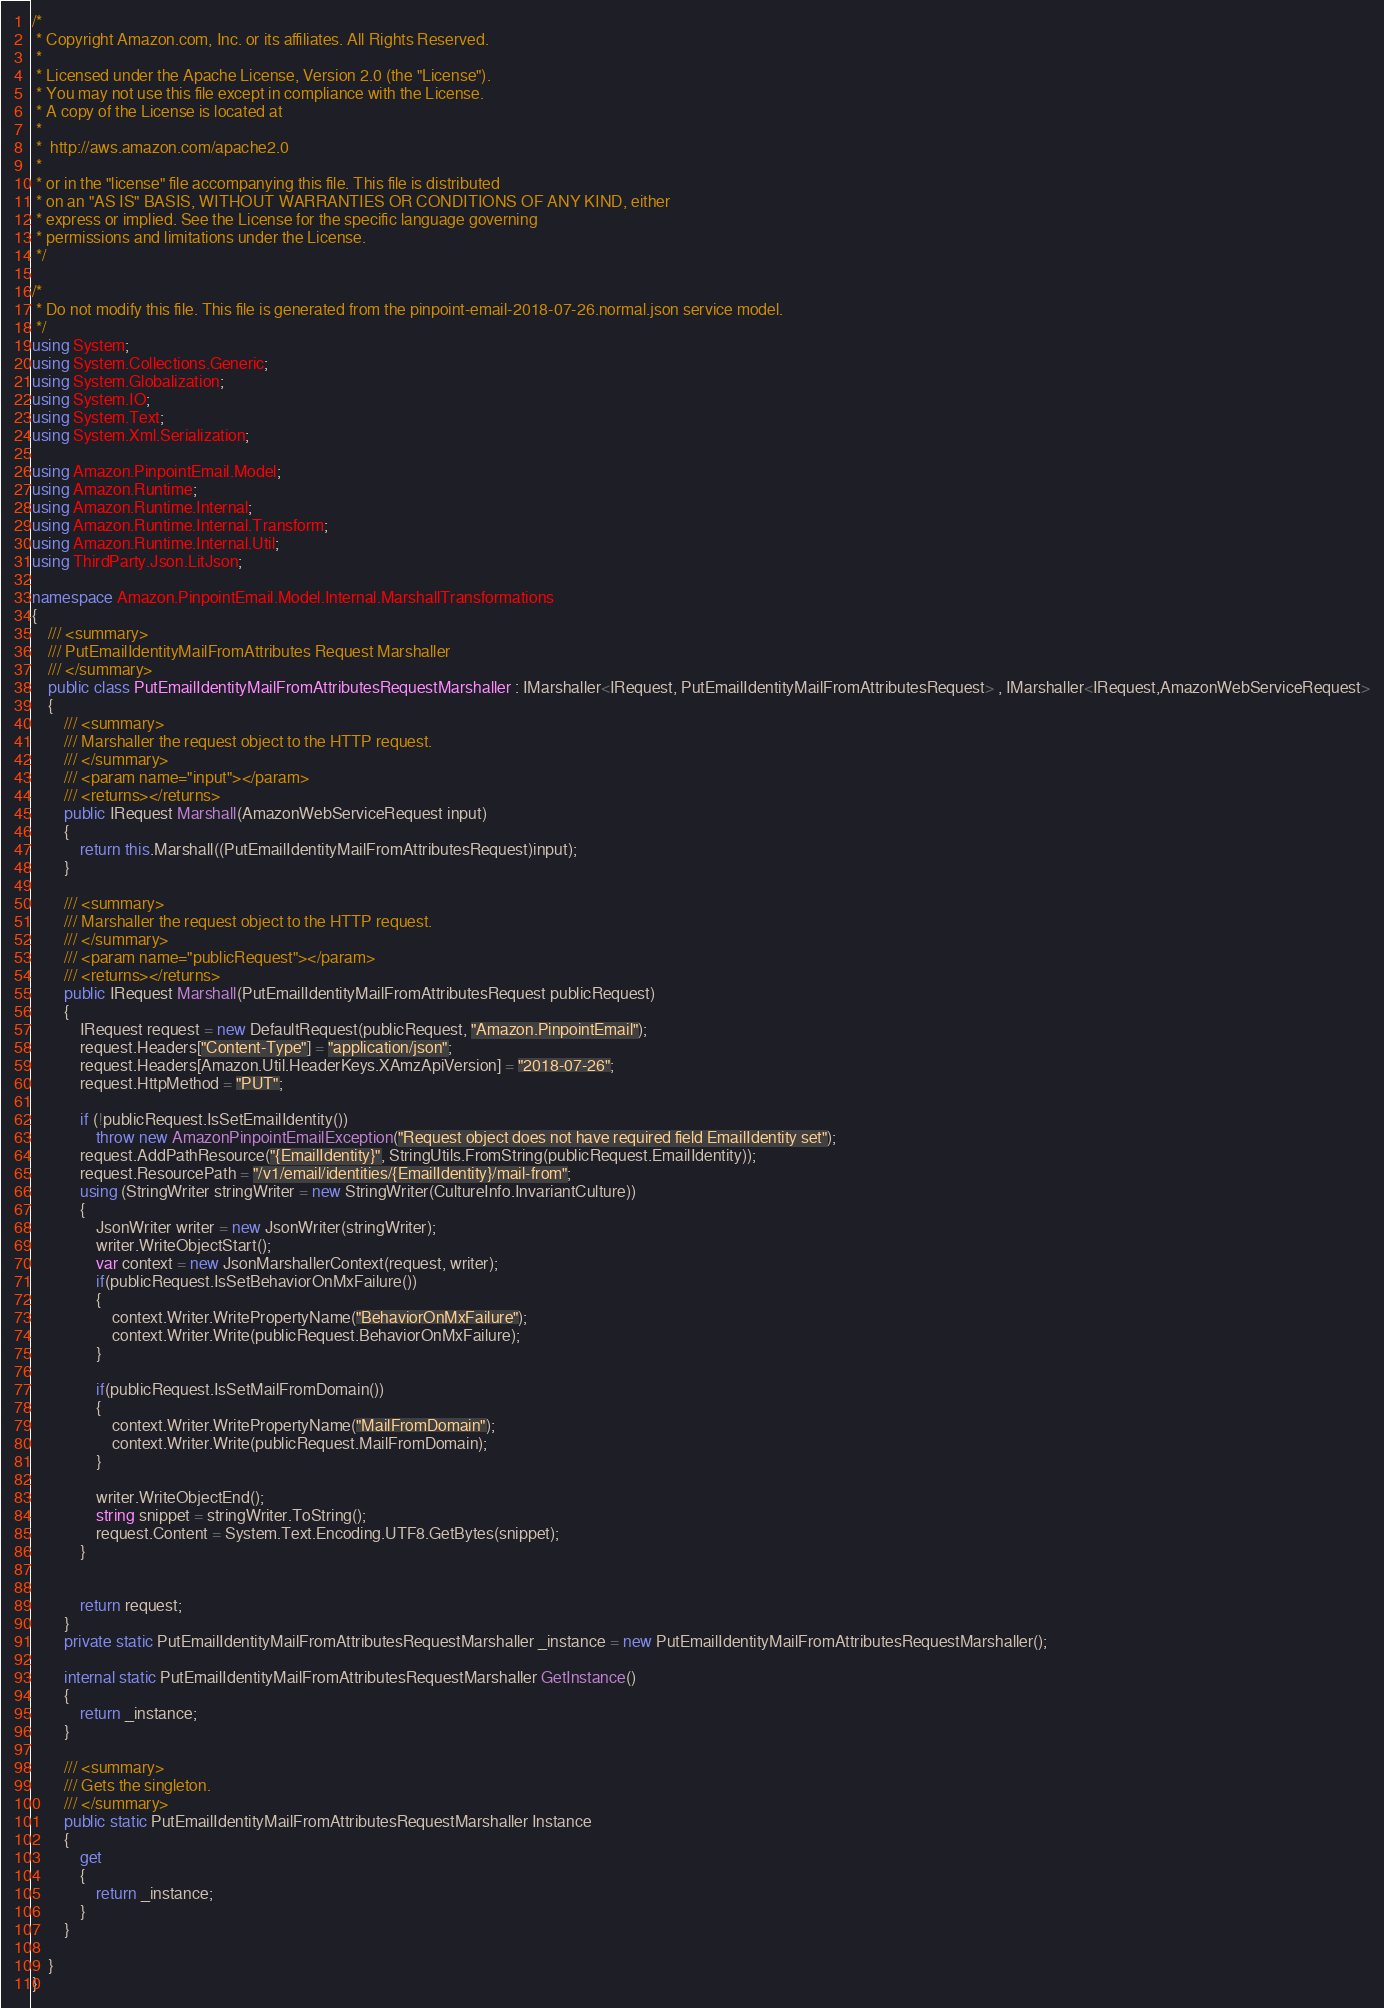<code> <loc_0><loc_0><loc_500><loc_500><_C#_>/*
 * Copyright Amazon.com, Inc. or its affiliates. All Rights Reserved.
 * 
 * Licensed under the Apache License, Version 2.0 (the "License").
 * You may not use this file except in compliance with the License.
 * A copy of the License is located at
 * 
 *  http://aws.amazon.com/apache2.0
 * 
 * or in the "license" file accompanying this file. This file is distributed
 * on an "AS IS" BASIS, WITHOUT WARRANTIES OR CONDITIONS OF ANY KIND, either
 * express or implied. See the License for the specific language governing
 * permissions and limitations under the License.
 */

/*
 * Do not modify this file. This file is generated from the pinpoint-email-2018-07-26.normal.json service model.
 */
using System;
using System.Collections.Generic;
using System.Globalization;
using System.IO;
using System.Text;
using System.Xml.Serialization;

using Amazon.PinpointEmail.Model;
using Amazon.Runtime;
using Amazon.Runtime.Internal;
using Amazon.Runtime.Internal.Transform;
using Amazon.Runtime.Internal.Util;
using ThirdParty.Json.LitJson;

namespace Amazon.PinpointEmail.Model.Internal.MarshallTransformations
{
    /// <summary>
    /// PutEmailIdentityMailFromAttributes Request Marshaller
    /// </summary>       
    public class PutEmailIdentityMailFromAttributesRequestMarshaller : IMarshaller<IRequest, PutEmailIdentityMailFromAttributesRequest> , IMarshaller<IRequest,AmazonWebServiceRequest>
    {
        /// <summary>
        /// Marshaller the request object to the HTTP request.
        /// </summary>  
        /// <param name="input"></param>
        /// <returns></returns>
        public IRequest Marshall(AmazonWebServiceRequest input)
        {
            return this.Marshall((PutEmailIdentityMailFromAttributesRequest)input);
        }

        /// <summary>
        /// Marshaller the request object to the HTTP request.
        /// </summary>  
        /// <param name="publicRequest"></param>
        /// <returns></returns>
        public IRequest Marshall(PutEmailIdentityMailFromAttributesRequest publicRequest)
        {
            IRequest request = new DefaultRequest(publicRequest, "Amazon.PinpointEmail");
            request.Headers["Content-Type"] = "application/json";
            request.Headers[Amazon.Util.HeaderKeys.XAmzApiVersion] = "2018-07-26";
            request.HttpMethod = "PUT";

            if (!publicRequest.IsSetEmailIdentity())
                throw new AmazonPinpointEmailException("Request object does not have required field EmailIdentity set");
            request.AddPathResource("{EmailIdentity}", StringUtils.FromString(publicRequest.EmailIdentity));
            request.ResourcePath = "/v1/email/identities/{EmailIdentity}/mail-from";
            using (StringWriter stringWriter = new StringWriter(CultureInfo.InvariantCulture))
            {
                JsonWriter writer = new JsonWriter(stringWriter);
                writer.WriteObjectStart();
                var context = new JsonMarshallerContext(request, writer);
                if(publicRequest.IsSetBehaviorOnMxFailure())
                {
                    context.Writer.WritePropertyName("BehaviorOnMxFailure");
                    context.Writer.Write(publicRequest.BehaviorOnMxFailure);
                }

                if(publicRequest.IsSetMailFromDomain())
                {
                    context.Writer.WritePropertyName("MailFromDomain");
                    context.Writer.Write(publicRequest.MailFromDomain);
                }

                writer.WriteObjectEnd();
                string snippet = stringWriter.ToString();
                request.Content = System.Text.Encoding.UTF8.GetBytes(snippet);
            }


            return request;
        }
        private static PutEmailIdentityMailFromAttributesRequestMarshaller _instance = new PutEmailIdentityMailFromAttributesRequestMarshaller();        

        internal static PutEmailIdentityMailFromAttributesRequestMarshaller GetInstance()
        {
            return _instance;
        }

        /// <summary>
        /// Gets the singleton.
        /// </summary>  
        public static PutEmailIdentityMailFromAttributesRequestMarshaller Instance
        {
            get
            {
                return _instance;
            }
        }

    }
}</code> 